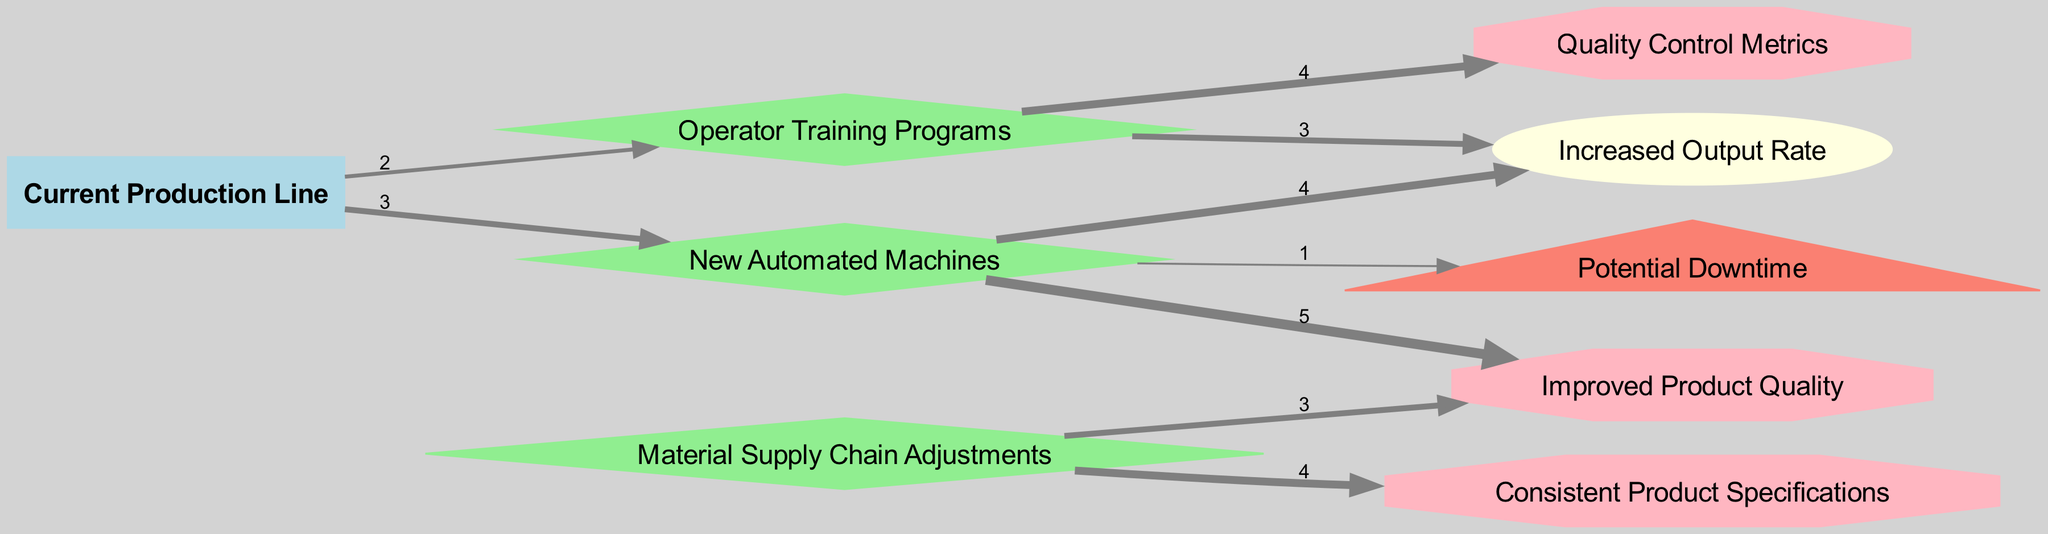What is the total number of nodes in the diagram? The diagram displays nine distinct nodes representing the current production line, changes to the production line, output metrics, quality metrics, and risks. By counting these nodes, we find a total of nine.
Answer: Nine What is the value of the link between "New Automated Machines" and "Improved Product Quality"? The link connecting "New Automated Machines" to "Improved Product Quality" has a value of five. This indicates the extent of impact from the automated machines on product quality.
Answer: Five How many changes source from the "Current Production Line"? From the "Current Production Line," there are two changes identified: "New Automated Machines" and "Operator Training Programs." These two indicate different methods of improving the production.
Answer: Two What does the link "Material Supply Chain Adjustments" lead to in terms of quality? The link "Material Supply Chain Adjustments" leads to "Improved Product Quality" and "Consistent Product Specifications." Each of these represents how supply chain changes support quality metrics.
Answer: Improved Product Quality, Consistent Product Specifications Which is the highest impact output resulting from "New Automated Machines"? The highest impact output resulting from "New Automated Machines" is "Improved Product Quality," which has the highest value of five in the diagram. This reflects a significant enhancement in quality due to automation.
Answer: Improved Product Quality What is the risk associated with "New Automated Machines"? The risk linked to "New Automated Machines" is "Potential Downtime," which has a value of one. This highlights a potential issue that might arise with the introduction of automated systems.
Answer: Potential Downtime How many outputs are influenced by "Operator Training Programs"? "Operator Training Programs" influences two outputs, namely "Increased Output Rate" and "Quality Control Metrics." Both metrics signify enhancements due to the training provided.
Answer: Two Is there a direct connection between "Material Supply Chain Adjustments" and output rates? There is no direct connection between "Material Supply Chain Adjustments" and output rates in the diagram. Instead, adjustments are linked to quality metrics, indicating that they impact quality rather than output directly.
Answer: No What are the two quality outputs alongside "Quality Control Metrics" that stem from "Operator Training Programs"? Alongside "Quality Control Metrics," "Operator Training Programs" leads to the output "Increased Output Rate." This illustrates that training contributes to both quality assessment and output enhancement.
Answer: Increased Output Rate 